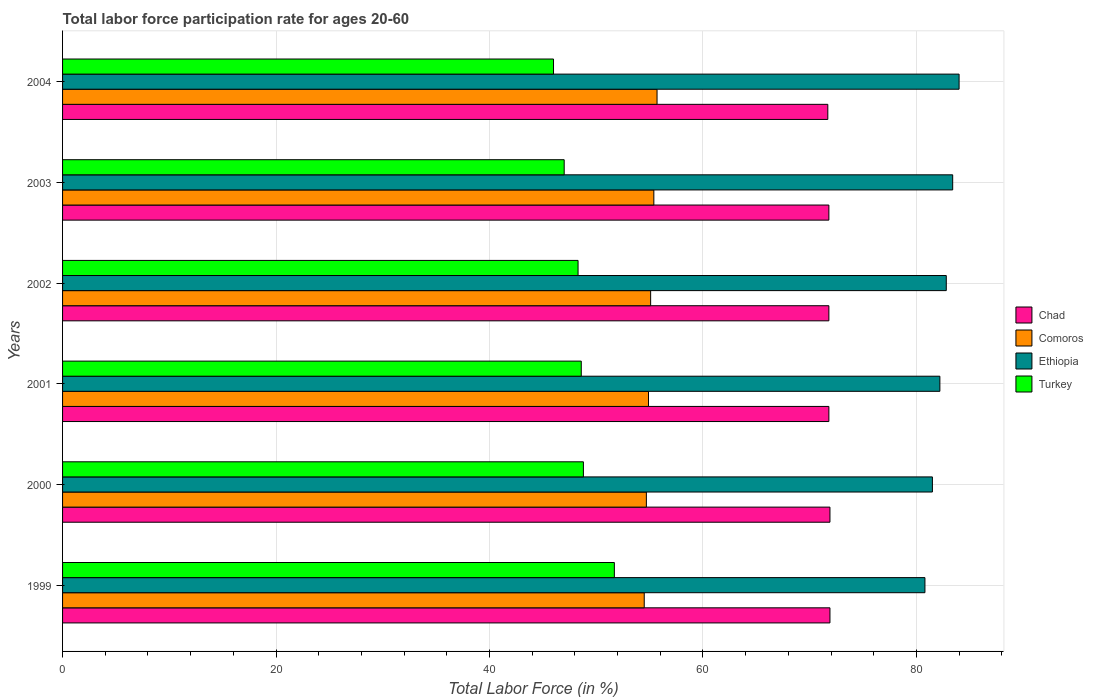How many different coloured bars are there?
Offer a very short reply. 4. Are the number of bars on each tick of the Y-axis equal?
Offer a terse response. Yes. How many bars are there on the 2nd tick from the top?
Offer a very short reply. 4. How many bars are there on the 4th tick from the bottom?
Keep it short and to the point. 4. What is the labor force participation rate in Chad in 1999?
Provide a succinct answer. 71.9. Across all years, what is the maximum labor force participation rate in Turkey?
Offer a terse response. 51.7. In which year was the labor force participation rate in Chad minimum?
Give a very brief answer. 2004. What is the total labor force participation rate in Turkey in the graph?
Keep it short and to the point. 290.4. What is the difference between the labor force participation rate in Ethiopia in 1999 and that in 2001?
Your answer should be very brief. -1.4. What is the difference between the labor force participation rate in Ethiopia in 2004 and the labor force participation rate in Comoros in 2000?
Your answer should be compact. 29.3. What is the average labor force participation rate in Ethiopia per year?
Offer a terse response. 82.45. In the year 2000, what is the difference between the labor force participation rate in Chad and labor force participation rate in Turkey?
Your answer should be compact. 23.1. What is the ratio of the labor force participation rate in Chad in 1999 to that in 2002?
Make the answer very short. 1. Is the labor force participation rate in Comoros in 1999 less than that in 2002?
Give a very brief answer. Yes. What is the difference between the highest and the second highest labor force participation rate in Comoros?
Your answer should be compact. 0.3. What is the difference between the highest and the lowest labor force participation rate in Ethiopia?
Ensure brevity in your answer.  3.2. Is it the case that in every year, the sum of the labor force participation rate in Chad and labor force participation rate in Ethiopia is greater than the labor force participation rate in Comoros?
Your answer should be compact. Yes. How many years are there in the graph?
Make the answer very short. 6. What is the difference between two consecutive major ticks on the X-axis?
Offer a very short reply. 20. Are the values on the major ticks of X-axis written in scientific E-notation?
Provide a succinct answer. No. Does the graph contain any zero values?
Your answer should be compact. No. How many legend labels are there?
Offer a terse response. 4. What is the title of the graph?
Your response must be concise. Total labor force participation rate for ages 20-60. Does "Caribbean small states" appear as one of the legend labels in the graph?
Your response must be concise. No. What is the Total Labor Force (in %) in Chad in 1999?
Provide a short and direct response. 71.9. What is the Total Labor Force (in %) of Comoros in 1999?
Give a very brief answer. 54.5. What is the Total Labor Force (in %) of Ethiopia in 1999?
Your answer should be compact. 80.8. What is the Total Labor Force (in %) of Turkey in 1999?
Give a very brief answer. 51.7. What is the Total Labor Force (in %) in Chad in 2000?
Ensure brevity in your answer.  71.9. What is the Total Labor Force (in %) in Comoros in 2000?
Make the answer very short. 54.7. What is the Total Labor Force (in %) of Ethiopia in 2000?
Give a very brief answer. 81.5. What is the Total Labor Force (in %) of Turkey in 2000?
Offer a very short reply. 48.8. What is the Total Labor Force (in %) in Chad in 2001?
Your answer should be compact. 71.8. What is the Total Labor Force (in %) of Comoros in 2001?
Your answer should be very brief. 54.9. What is the Total Labor Force (in %) of Ethiopia in 2001?
Offer a very short reply. 82.2. What is the Total Labor Force (in %) of Turkey in 2001?
Offer a terse response. 48.6. What is the Total Labor Force (in %) of Chad in 2002?
Make the answer very short. 71.8. What is the Total Labor Force (in %) in Comoros in 2002?
Provide a succinct answer. 55.1. What is the Total Labor Force (in %) in Ethiopia in 2002?
Your answer should be compact. 82.8. What is the Total Labor Force (in %) in Turkey in 2002?
Provide a succinct answer. 48.3. What is the Total Labor Force (in %) of Chad in 2003?
Make the answer very short. 71.8. What is the Total Labor Force (in %) of Comoros in 2003?
Your answer should be very brief. 55.4. What is the Total Labor Force (in %) in Ethiopia in 2003?
Your answer should be very brief. 83.4. What is the Total Labor Force (in %) of Chad in 2004?
Provide a succinct answer. 71.7. What is the Total Labor Force (in %) in Comoros in 2004?
Make the answer very short. 55.7. Across all years, what is the maximum Total Labor Force (in %) in Chad?
Your answer should be very brief. 71.9. Across all years, what is the maximum Total Labor Force (in %) of Comoros?
Offer a terse response. 55.7. Across all years, what is the maximum Total Labor Force (in %) of Turkey?
Your response must be concise. 51.7. Across all years, what is the minimum Total Labor Force (in %) in Chad?
Provide a short and direct response. 71.7. Across all years, what is the minimum Total Labor Force (in %) of Comoros?
Your response must be concise. 54.5. Across all years, what is the minimum Total Labor Force (in %) of Ethiopia?
Provide a short and direct response. 80.8. Across all years, what is the minimum Total Labor Force (in %) in Turkey?
Ensure brevity in your answer.  46. What is the total Total Labor Force (in %) in Chad in the graph?
Provide a succinct answer. 430.9. What is the total Total Labor Force (in %) of Comoros in the graph?
Ensure brevity in your answer.  330.3. What is the total Total Labor Force (in %) in Ethiopia in the graph?
Offer a very short reply. 494.7. What is the total Total Labor Force (in %) in Turkey in the graph?
Your answer should be compact. 290.4. What is the difference between the Total Labor Force (in %) in Chad in 1999 and that in 2000?
Give a very brief answer. 0. What is the difference between the Total Labor Force (in %) in Turkey in 1999 and that in 2001?
Keep it short and to the point. 3.1. What is the difference between the Total Labor Force (in %) in Chad in 1999 and that in 2002?
Provide a succinct answer. 0.1. What is the difference between the Total Labor Force (in %) in Turkey in 1999 and that in 2002?
Make the answer very short. 3.4. What is the difference between the Total Labor Force (in %) in Chad in 1999 and that in 2004?
Keep it short and to the point. 0.2. What is the difference between the Total Labor Force (in %) in Comoros in 1999 and that in 2004?
Keep it short and to the point. -1.2. What is the difference between the Total Labor Force (in %) in Turkey in 2000 and that in 2001?
Your answer should be very brief. 0.2. What is the difference between the Total Labor Force (in %) in Comoros in 2000 and that in 2002?
Give a very brief answer. -0.4. What is the difference between the Total Labor Force (in %) of Turkey in 2000 and that in 2002?
Provide a succinct answer. 0.5. What is the difference between the Total Labor Force (in %) in Turkey in 2000 and that in 2003?
Make the answer very short. 1.8. What is the difference between the Total Labor Force (in %) in Chad in 2000 and that in 2004?
Your answer should be compact. 0.2. What is the difference between the Total Labor Force (in %) of Comoros in 2000 and that in 2004?
Provide a short and direct response. -1. What is the difference between the Total Labor Force (in %) in Ethiopia in 2000 and that in 2004?
Your answer should be compact. -2.5. What is the difference between the Total Labor Force (in %) of Turkey in 2000 and that in 2004?
Your answer should be compact. 2.8. What is the difference between the Total Labor Force (in %) in Chad in 2001 and that in 2002?
Your response must be concise. 0. What is the difference between the Total Labor Force (in %) of Turkey in 2001 and that in 2002?
Your answer should be compact. 0.3. What is the difference between the Total Labor Force (in %) of Chad in 2001 and that in 2003?
Offer a terse response. 0. What is the difference between the Total Labor Force (in %) in Comoros in 2001 and that in 2003?
Ensure brevity in your answer.  -0.5. What is the difference between the Total Labor Force (in %) of Ethiopia in 2001 and that in 2003?
Ensure brevity in your answer.  -1.2. What is the difference between the Total Labor Force (in %) of Chad in 2001 and that in 2004?
Give a very brief answer. 0.1. What is the difference between the Total Labor Force (in %) in Comoros in 2001 and that in 2004?
Keep it short and to the point. -0.8. What is the difference between the Total Labor Force (in %) of Ethiopia in 2001 and that in 2004?
Provide a short and direct response. -1.8. What is the difference between the Total Labor Force (in %) of Chad in 2002 and that in 2003?
Keep it short and to the point. 0. What is the difference between the Total Labor Force (in %) of Comoros in 2002 and that in 2003?
Make the answer very short. -0.3. What is the difference between the Total Labor Force (in %) of Comoros in 2002 and that in 2004?
Provide a short and direct response. -0.6. What is the difference between the Total Labor Force (in %) in Chad in 2003 and that in 2004?
Your answer should be very brief. 0.1. What is the difference between the Total Labor Force (in %) of Chad in 1999 and the Total Labor Force (in %) of Comoros in 2000?
Your answer should be compact. 17.2. What is the difference between the Total Labor Force (in %) in Chad in 1999 and the Total Labor Force (in %) in Ethiopia in 2000?
Give a very brief answer. -9.6. What is the difference between the Total Labor Force (in %) of Chad in 1999 and the Total Labor Force (in %) of Turkey in 2000?
Offer a terse response. 23.1. What is the difference between the Total Labor Force (in %) of Comoros in 1999 and the Total Labor Force (in %) of Ethiopia in 2000?
Your response must be concise. -27. What is the difference between the Total Labor Force (in %) of Ethiopia in 1999 and the Total Labor Force (in %) of Turkey in 2000?
Provide a short and direct response. 32. What is the difference between the Total Labor Force (in %) in Chad in 1999 and the Total Labor Force (in %) in Comoros in 2001?
Ensure brevity in your answer.  17. What is the difference between the Total Labor Force (in %) of Chad in 1999 and the Total Labor Force (in %) of Ethiopia in 2001?
Provide a succinct answer. -10.3. What is the difference between the Total Labor Force (in %) in Chad in 1999 and the Total Labor Force (in %) in Turkey in 2001?
Keep it short and to the point. 23.3. What is the difference between the Total Labor Force (in %) in Comoros in 1999 and the Total Labor Force (in %) in Ethiopia in 2001?
Your answer should be compact. -27.7. What is the difference between the Total Labor Force (in %) of Ethiopia in 1999 and the Total Labor Force (in %) of Turkey in 2001?
Provide a succinct answer. 32.2. What is the difference between the Total Labor Force (in %) of Chad in 1999 and the Total Labor Force (in %) of Comoros in 2002?
Offer a very short reply. 16.8. What is the difference between the Total Labor Force (in %) of Chad in 1999 and the Total Labor Force (in %) of Turkey in 2002?
Provide a succinct answer. 23.6. What is the difference between the Total Labor Force (in %) in Comoros in 1999 and the Total Labor Force (in %) in Ethiopia in 2002?
Keep it short and to the point. -28.3. What is the difference between the Total Labor Force (in %) of Ethiopia in 1999 and the Total Labor Force (in %) of Turkey in 2002?
Make the answer very short. 32.5. What is the difference between the Total Labor Force (in %) in Chad in 1999 and the Total Labor Force (in %) in Comoros in 2003?
Offer a very short reply. 16.5. What is the difference between the Total Labor Force (in %) in Chad in 1999 and the Total Labor Force (in %) in Ethiopia in 2003?
Make the answer very short. -11.5. What is the difference between the Total Labor Force (in %) in Chad in 1999 and the Total Labor Force (in %) in Turkey in 2003?
Give a very brief answer. 24.9. What is the difference between the Total Labor Force (in %) in Comoros in 1999 and the Total Labor Force (in %) in Ethiopia in 2003?
Your response must be concise. -28.9. What is the difference between the Total Labor Force (in %) of Ethiopia in 1999 and the Total Labor Force (in %) of Turkey in 2003?
Offer a very short reply. 33.8. What is the difference between the Total Labor Force (in %) of Chad in 1999 and the Total Labor Force (in %) of Ethiopia in 2004?
Provide a short and direct response. -12.1. What is the difference between the Total Labor Force (in %) in Chad in 1999 and the Total Labor Force (in %) in Turkey in 2004?
Give a very brief answer. 25.9. What is the difference between the Total Labor Force (in %) in Comoros in 1999 and the Total Labor Force (in %) in Ethiopia in 2004?
Provide a short and direct response. -29.5. What is the difference between the Total Labor Force (in %) of Comoros in 1999 and the Total Labor Force (in %) of Turkey in 2004?
Offer a very short reply. 8.5. What is the difference between the Total Labor Force (in %) in Ethiopia in 1999 and the Total Labor Force (in %) in Turkey in 2004?
Make the answer very short. 34.8. What is the difference between the Total Labor Force (in %) of Chad in 2000 and the Total Labor Force (in %) of Comoros in 2001?
Your answer should be very brief. 17. What is the difference between the Total Labor Force (in %) of Chad in 2000 and the Total Labor Force (in %) of Ethiopia in 2001?
Ensure brevity in your answer.  -10.3. What is the difference between the Total Labor Force (in %) in Chad in 2000 and the Total Labor Force (in %) in Turkey in 2001?
Offer a terse response. 23.3. What is the difference between the Total Labor Force (in %) in Comoros in 2000 and the Total Labor Force (in %) in Ethiopia in 2001?
Provide a short and direct response. -27.5. What is the difference between the Total Labor Force (in %) of Comoros in 2000 and the Total Labor Force (in %) of Turkey in 2001?
Your response must be concise. 6.1. What is the difference between the Total Labor Force (in %) of Ethiopia in 2000 and the Total Labor Force (in %) of Turkey in 2001?
Offer a terse response. 32.9. What is the difference between the Total Labor Force (in %) of Chad in 2000 and the Total Labor Force (in %) of Turkey in 2002?
Ensure brevity in your answer.  23.6. What is the difference between the Total Labor Force (in %) in Comoros in 2000 and the Total Labor Force (in %) in Ethiopia in 2002?
Provide a succinct answer. -28.1. What is the difference between the Total Labor Force (in %) of Ethiopia in 2000 and the Total Labor Force (in %) of Turkey in 2002?
Your response must be concise. 33.2. What is the difference between the Total Labor Force (in %) in Chad in 2000 and the Total Labor Force (in %) in Comoros in 2003?
Offer a terse response. 16.5. What is the difference between the Total Labor Force (in %) of Chad in 2000 and the Total Labor Force (in %) of Turkey in 2003?
Make the answer very short. 24.9. What is the difference between the Total Labor Force (in %) in Comoros in 2000 and the Total Labor Force (in %) in Ethiopia in 2003?
Your answer should be compact. -28.7. What is the difference between the Total Labor Force (in %) of Ethiopia in 2000 and the Total Labor Force (in %) of Turkey in 2003?
Provide a short and direct response. 34.5. What is the difference between the Total Labor Force (in %) in Chad in 2000 and the Total Labor Force (in %) in Ethiopia in 2004?
Offer a very short reply. -12.1. What is the difference between the Total Labor Force (in %) of Chad in 2000 and the Total Labor Force (in %) of Turkey in 2004?
Provide a short and direct response. 25.9. What is the difference between the Total Labor Force (in %) of Comoros in 2000 and the Total Labor Force (in %) of Ethiopia in 2004?
Offer a terse response. -29.3. What is the difference between the Total Labor Force (in %) in Comoros in 2000 and the Total Labor Force (in %) in Turkey in 2004?
Offer a very short reply. 8.7. What is the difference between the Total Labor Force (in %) in Ethiopia in 2000 and the Total Labor Force (in %) in Turkey in 2004?
Your answer should be compact. 35.5. What is the difference between the Total Labor Force (in %) in Comoros in 2001 and the Total Labor Force (in %) in Ethiopia in 2002?
Provide a succinct answer. -27.9. What is the difference between the Total Labor Force (in %) in Comoros in 2001 and the Total Labor Force (in %) in Turkey in 2002?
Keep it short and to the point. 6.6. What is the difference between the Total Labor Force (in %) of Ethiopia in 2001 and the Total Labor Force (in %) of Turkey in 2002?
Your answer should be very brief. 33.9. What is the difference between the Total Labor Force (in %) of Chad in 2001 and the Total Labor Force (in %) of Turkey in 2003?
Offer a terse response. 24.8. What is the difference between the Total Labor Force (in %) of Comoros in 2001 and the Total Labor Force (in %) of Ethiopia in 2003?
Give a very brief answer. -28.5. What is the difference between the Total Labor Force (in %) of Comoros in 2001 and the Total Labor Force (in %) of Turkey in 2003?
Provide a succinct answer. 7.9. What is the difference between the Total Labor Force (in %) in Ethiopia in 2001 and the Total Labor Force (in %) in Turkey in 2003?
Your answer should be very brief. 35.2. What is the difference between the Total Labor Force (in %) of Chad in 2001 and the Total Labor Force (in %) of Turkey in 2004?
Offer a terse response. 25.8. What is the difference between the Total Labor Force (in %) of Comoros in 2001 and the Total Labor Force (in %) of Ethiopia in 2004?
Give a very brief answer. -29.1. What is the difference between the Total Labor Force (in %) in Ethiopia in 2001 and the Total Labor Force (in %) in Turkey in 2004?
Provide a succinct answer. 36.2. What is the difference between the Total Labor Force (in %) of Chad in 2002 and the Total Labor Force (in %) of Ethiopia in 2003?
Offer a terse response. -11.6. What is the difference between the Total Labor Force (in %) of Chad in 2002 and the Total Labor Force (in %) of Turkey in 2003?
Offer a very short reply. 24.8. What is the difference between the Total Labor Force (in %) of Comoros in 2002 and the Total Labor Force (in %) of Ethiopia in 2003?
Your response must be concise. -28.3. What is the difference between the Total Labor Force (in %) of Ethiopia in 2002 and the Total Labor Force (in %) of Turkey in 2003?
Offer a very short reply. 35.8. What is the difference between the Total Labor Force (in %) in Chad in 2002 and the Total Labor Force (in %) in Comoros in 2004?
Your answer should be compact. 16.1. What is the difference between the Total Labor Force (in %) of Chad in 2002 and the Total Labor Force (in %) of Turkey in 2004?
Give a very brief answer. 25.8. What is the difference between the Total Labor Force (in %) in Comoros in 2002 and the Total Labor Force (in %) in Ethiopia in 2004?
Your response must be concise. -28.9. What is the difference between the Total Labor Force (in %) in Comoros in 2002 and the Total Labor Force (in %) in Turkey in 2004?
Make the answer very short. 9.1. What is the difference between the Total Labor Force (in %) in Ethiopia in 2002 and the Total Labor Force (in %) in Turkey in 2004?
Your response must be concise. 36.8. What is the difference between the Total Labor Force (in %) in Chad in 2003 and the Total Labor Force (in %) in Turkey in 2004?
Ensure brevity in your answer.  25.8. What is the difference between the Total Labor Force (in %) of Comoros in 2003 and the Total Labor Force (in %) of Ethiopia in 2004?
Provide a succinct answer. -28.6. What is the difference between the Total Labor Force (in %) of Ethiopia in 2003 and the Total Labor Force (in %) of Turkey in 2004?
Keep it short and to the point. 37.4. What is the average Total Labor Force (in %) in Chad per year?
Provide a succinct answer. 71.82. What is the average Total Labor Force (in %) of Comoros per year?
Your answer should be very brief. 55.05. What is the average Total Labor Force (in %) in Ethiopia per year?
Give a very brief answer. 82.45. What is the average Total Labor Force (in %) in Turkey per year?
Offer a terse response. 48.4. In the year 1999, what is the difference between the Total Labor Force (in %) in Chad and Total Labor Force (in %) in Ethiopia?
Your answer should be very brief. -8.9. In the year 1999, what is the difference between the Total Labor Force (in %) of Chad and Total Labor Force (in %) of Turkey?
Offer a terse response. 20.2. In the year 1999, what is the difference between the Total Labor Force (in %) of Comoros and Total Labor Force (in %) of Ethiopia?
Your answer should be very brief. -26.3. In the year 1999, what is the difference between the Total Labor Force (in %) of Ethiopia and Total Labor Force (in %) of Turkey?
Keep it short and to the point. 29.1. In the year 2000, what is the difference between the Total Labor Force (in %) of Chad and Total Labor Force (in %) of Comoros?
Provide a succinct answer. 17.2. In the year 2000, what is the difference between the Total Labor Force (in %) in Chad and Total Labor Force (in %) in Turkey?
Provide a short and direct response. 23.1. In the year 2000, what is the difference between the Total Labor Force (in %) of Comoros and Total Labor Force (in %) of Ethiopia?
Give a very brief answer. -26.8. In the year 2000, what is the difference between the Total Labor Force (in %) in Ethiopia and Total Labor Force (in %) in Turkey?
Your answer should be compact. 32.7. In the year 2001, what is the difference between the Total Labor Force (in %) of Chad and Total Labor Force (in %) of Turkey?
Your answer should be compact. 23.2. In the year 2001, what is the difference between the Total Labor Force (in %) in Comoros and Total Labor Force (in %) in Ethiopia?
Offer a very short reply. -27.3. In the year 2001, what is the difference between the Total Labor Force (in %) in Comoros and Total Labor Force (in %) in Turkey?
Offer a terse response. 6.3. In the year 2001, what is the difference between the Total Labor Force (in %) of Ethiopia and Total Labor Force (in %) of Turkey?
Your answer should be very brief. 33.6. In the year 2002, what is the difference between the Total Labor Force (in %) in Chad and Total Labor Force (in %) in Comoros?
Provide a short and direct response. 16.7. In the year 2002, what is the difference between the Total Labor Force (in %) of Chad and Total Labor Force (in %) of Ethiopia?
Keep it short and to the point. -11. In the year 2002, what is the difference between the Total Labor Force (in %) in Comoros and Total Labor Force (in %) in Ethiopia?
Keep it short and to the point. -27.7. In the year 2002, what is the difference between the Total Labor Force (in %) in Comoros and Total Labor Force (in %) in Turkey?
Ensure brevity in your answer.  6.8. In the year 2002, what is the difference between the Total Labor Force (in %) in Ethiopia and Total Labor Force (in %) in Turkey?
Make the answer very short. 34.5. In the year 2003, what is the difference between the Total Labor Force (in %) of Chad and Total Labor Force (in %) of Comoros?
Offer a very short reply. 16.4. In the year 2003, what is the difference between the Total Labor Force (in %) in Chad and Total Labor Force (in %) in Turkey?
Offer a terse response. 24.8. In the year 2003, what is the difference between the Total Labor Force (in %) of Comoros and Total Labor Force (in %) of Ethiopia?
Keep it short and to the point. -28. In the year 2003, what is the difference between the Total Labor Force (in %) of Ethiopia and Total Labor Force (in %) of Turkey?
Give a very brief answer. 36.4. In the year 2004, what is the difference between the Total Labor Force (in %) in Chad and Total Labor Force (in %) in Turkey?
Your response must be concise. 25.7. In the year 2004, what is the difference between the Total Labor Force (in %) in Comoros and Total Labor Force (in %) in Ethiopia?
Provide a succinct answer. -28.3. In the year 2004, what is the difference between the Total Labor Force (in %) of Comoros and Total Labor Force (in %) of Turkey?
Your response must be concise. 9.7. What is the ratio of the Total Labor Force (in %) of Chad in 1999 to that in 2000?
Ensure brevity in your answer.  1. What is the ratio of the Total Labor Force (in %) of Comoros in 1999 to that in 2000?
Provide a short and direct response. 1. What is the ratio of the Total Labor Force (in %) of Ethiopia in 1999 to that in 2000?
Give a very brief answer. 0.99. What is the ratio of the Total Labor Force (in %) of Turkey in 1999 to that in 2000?
Keep it short and to the point. 1.06. What is the ratio of the Total Labor Force (in %) in Ethiopia in 1999 to that in 2001?
Your answer should be compact. 0.98. What is the ratio of the Total Labor Force (in %) in Turkey in 1999 to that in 2001?
Your answer should be compact. 1.06. What is the ratio of the Total Labor Force (in %) in Ethiopia in 1999 to that in 2002?
Keep it short and to the point. 0.98. What is the ratio of the Total Labor Force (in %) in Turkey in 1999 to that in 2002?
Your answer should be very brief. 1.07. What is the ratio of the Total Labor Force (in %) in Comoros in 1999 to that in 2003?
Offer a terse response. 0.98. What is the ratio of the Total Labor Force (in %) of Ethiopia in 1999 to that in 2003?
Offer a very short reply. 0.97. What is the ratio of the Total Labor Force (in %) of Turkey in 1999 to that in 2003?
Offer a terse response. 1.1. What is the ratio of the Total Labor Force (in %) of Comoros in 1999 to that in 2004?
Offer a very short reply. 0.98. What is the ratio of the Total Labor Force (in %) of Ethiopia in 1999 to that in 2004?
Your answer should be very brief. 0.96. What is the ratio of the Total Labor Force (in %) of Turkey in 1999 to that in 2004?
Make the answer very short. 1.12. What is the ratio of the Total Labor Force (in %) in Chad in 2000 to that in 2001?
Ensure brevity in your answer.  1. What is the ratio of the Total Labor Force (in %) in Ethiopia in 2000 to that in 2001?
Your answer should be very brief. 0.99. What is the ratio of the Total Labor Force (in %) in Chad in 2000 to that in 2002?
Offer a very short reply. 1. What is the ratio of the Total Labor Force (in %) in Ethiopia in 2000 to that in 2002?
Provide a short and direct response. 0.98. What is the ratio of the Total Labor Force (in %) of Turkey in 2000 to that in 2002?
Provide a succinct answer. 1.01. What is the ratio of the Total Labor Force (in %) in Chad in 2000 to that in 2003?
Offer a very short reply. 1. What is the ratio of the Total Labor Force (in %) in Comoros in 2000 to that in 2003?
Make the answer very short. 0.99. What is the ratio of the Total Labor Force (in %) in Ethiopia in 2000 to that in 2003?
Provide a succinct answer. 0.98. What is the ratio of the Total Labor Force (in %) in Turkey in 2000 to that in 2003?
Make the answer very short. 1.04. What is the ratio of the Total Labor Force (in %) in Comoros in 2000 to that in 2004?
Keep it short and to the point. 0.98. What is the ratio of the Total Labor Force (in %) of Ethiopia in 2000 to that in 2004?
Make the answer very short. 0.97. What is the ratio of the Total Labor Force (in %) of Turkey in 2000 to that in 2004?
Offer a terse response. 1.06. What is the ratio of the Total Labor Force (in %) of Chad in 2001 to that in 2002?
Ensure brevity in your answer.  1. What is the ratio of the Total Labor Force (in %) in Comoros in 2001 to that in 2002?
Ensure brevity in your answer.  1. What is the ratio of the Total Labor Force (in %) in Ethiopia in 2001 to that in 2002?
Your response must be concise. 0.99. What is the ratio of the Total Labor Force (in %) in Chad in 2001 to that in 2003?
Make the answer very short. 1. What is the ratio of the Total Labor Force (in %) of Ethiopia in 2001 to that in 2003?
Offer a very short reply. 0.99. What is the ratio of the Total Labor Force (in %) in Turkey in 2001 to that in 2003?
Your answer should be very brief. 1.03. What is the ratio of the Total Labor Force (in %) of Comoros in 2001 to that in 2004?
Give a very brief answer. 0.99. What is the ratio of the Total Labor Force (in %) in Ethiopia in 2001 to that in 2004?
Give a very brief answer. 0.98. What is the ratio of the Total Labor Force (in %) in Turkey in 2001 to that in 2004?
Make the answer very short. 1.06. What is the ratio of the Total Labor Force (in %) in Turkey in 2002 to that in 2003?
Make the answer very short. 1.03. What is the ratio of the Total Labor Force (in %) of Chad in 2002 to that in 2004?
Provide a succinct answer. 1. What is the ratio of the Total Labor Force (in %) in Comoros in 2002 to that in 2004?
Your answer should be compact. 0.99. What is the ratio of the Total Labor Force (in %) of Ethiopia in 2002 to that in 2004?
Your answer should be very brief. 0.99. What is the ratio of the Total Labor Force (in %) of Chad in 2003 to that in 2004?
Give a very brief answer. 1. What is the ratio of the Total Labor Force (in %) in Ethiopia in 2003 to that in 2004?
Your answer should be very brief. 0.99. What is the ratio of the Total Labor Force (in %) of Turkey in 2003 to that in 2004?
Your answer should be compact. 1.02. What is the difference between the highest and the second highest Total Labor Force (in %) of Comoros?
Keep it short and to the point. 0.3. What is the difference between the highest and the second highest Total Labor Force (in %) of Ethiopia?
Your answer should be compact. 0.6. What is the difference between the highest and the lowest Total Labor Force (in %) in Chad?
Offer a terse response. 0.2. What is the difference between the highest and the lowest Total Labor Force (in %) of Ethiopia?
Ensure brevity in your answer.  3.2. What is the difference between the highest and the lowest Total Labor Force (in %) of Turkey?
Make the answer very short. 5.7. 